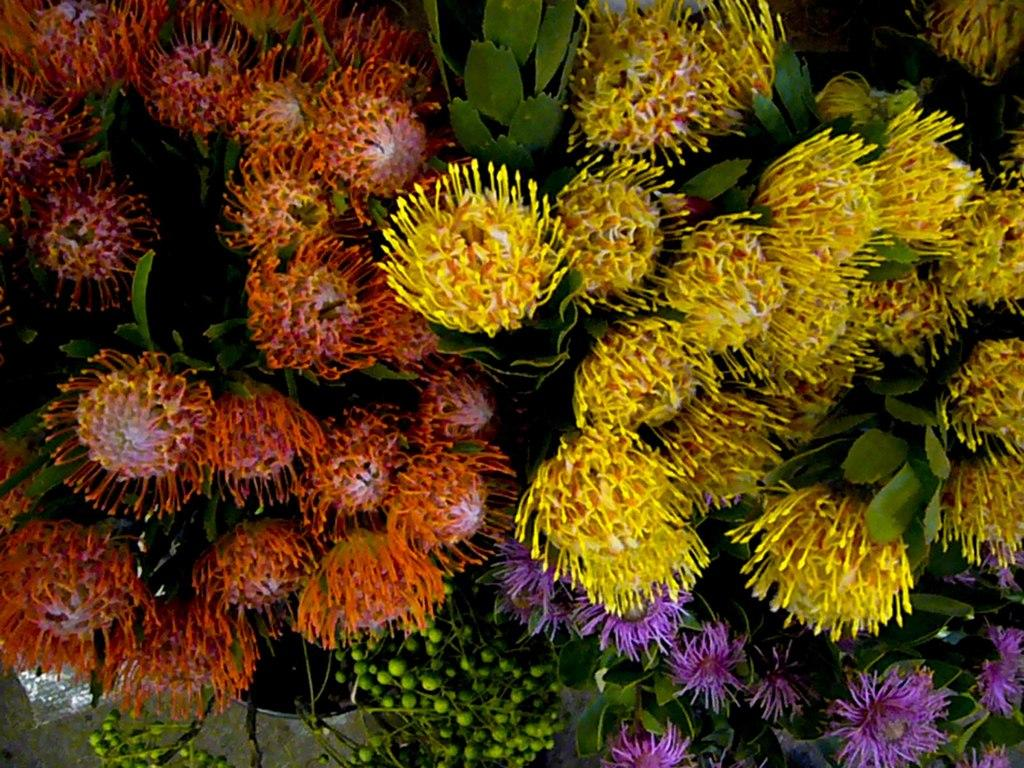What type of plants can be seen in the image? There are aquatic plants in the image. Where are the aquatic plants located? The aquatic plants are present in water. What type of pest can be seen attacking the aquatic plants in the image? There is no pest present in the image; it only features aquatic plants in water. What tool is used to rake the aquatic plants in the image? There is no tool or raking activity depicted in the image; it only shows aquatic plants in water. 